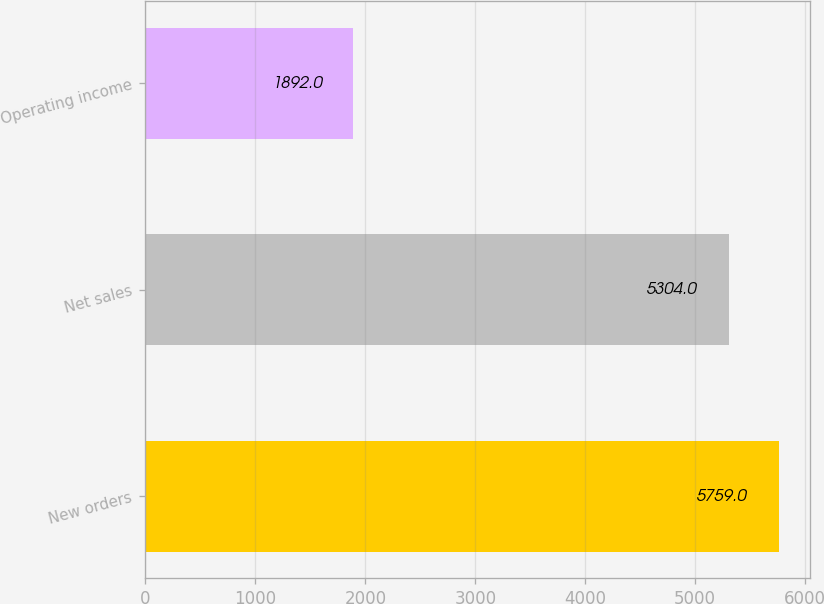<chart> <loc_0><loc_0><loc_500><loc_500><bar_chart><fcel>New orders<fcel>Net sales<fcel>Operating income<nl><fcel>5759<fcel>5304<fcel>1892<nl></chart> 